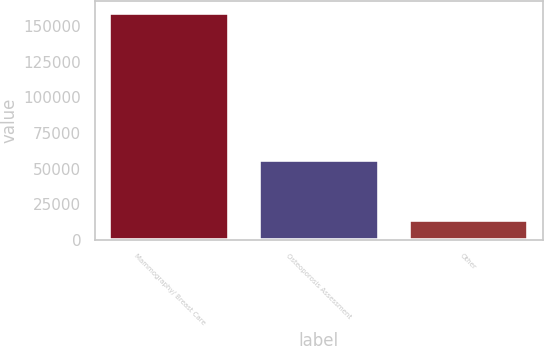<chart> <loc_0><loc_0><loc_500><loc_500><bar_chart><fcel>Mammography/ Breast Care<fcel>Osteoporosis Assessment<fcel>Other<nl><fcel>159469<fcel>56065<fcel>13541<nl></chart> 